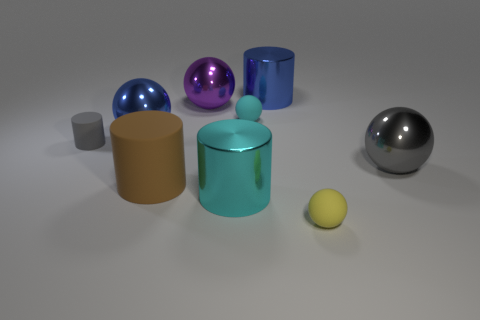Subtract 1 cylinders. How many cylinders are left? 3 Subtract all brown balls. Subtract all red cylinders. How many balls are left? 5 Add 1 brown metal cylinders. How many objects exist? 10 Subtract all cylinders. How many objects are left? 5 Subtract all large yellow balls. Subtract all brown things. How many objects are left? 8 Add 3 cyan cylinders. How many cyan cylinders are left? 4 Add 4 big cylinders. How many big cylinders exist? 7 Subtract 0 purple cubes. How many objects are left? 9 